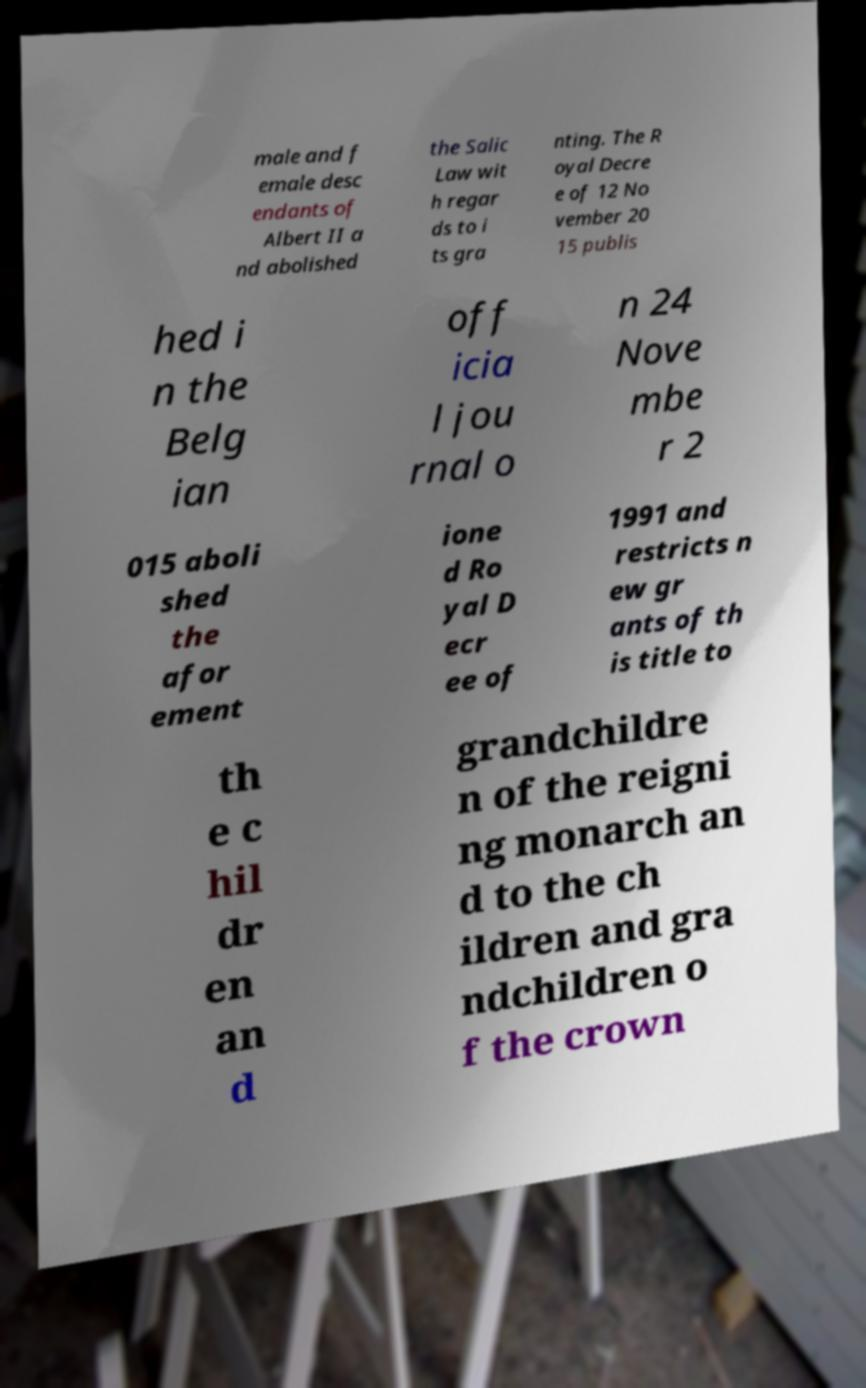Can you accurately transcribe the text from the provided image for me? male and f emale desc endants of Albert II a nd abolished the Salic Law wit h regar ds to i ts gra nting. The R oyal Decre e of 12 No vember 20 15 publis hed i n the Belg ian off icia l jou rnal o n 24 Nove mbe r 2 015 aboli shed the afor ement ione d Ro yal D ecr ee of 1991 and restricts n ew gr ants of th is title to th e c hil dr en an d grandchildre n of the reigni ng monarch an d to the ch ildren and gra ndchildren o f the crown 